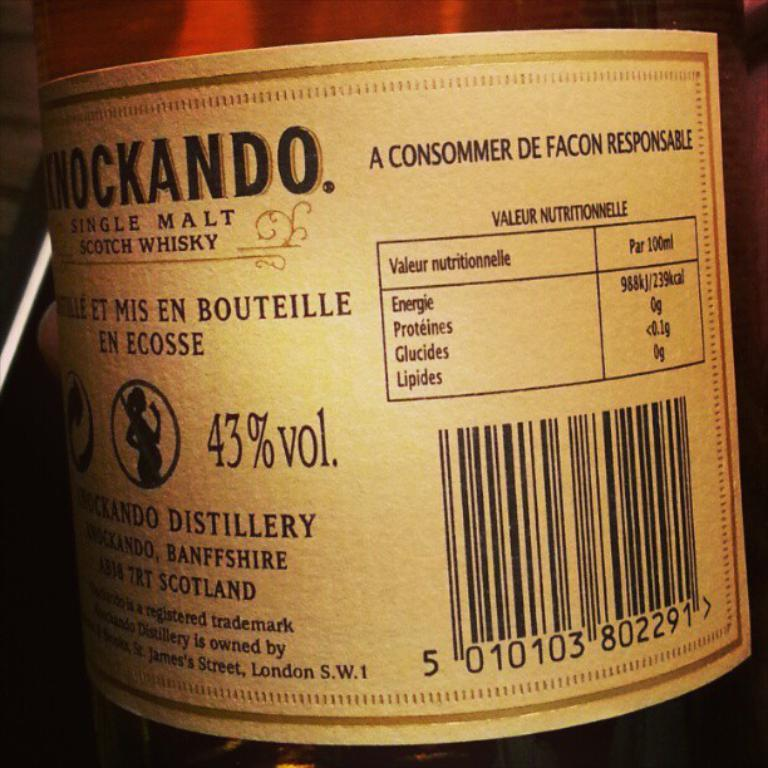<image>
Give a short and clear explanation of the subsequent image. A label for malt whiskey gives nutrition information. 